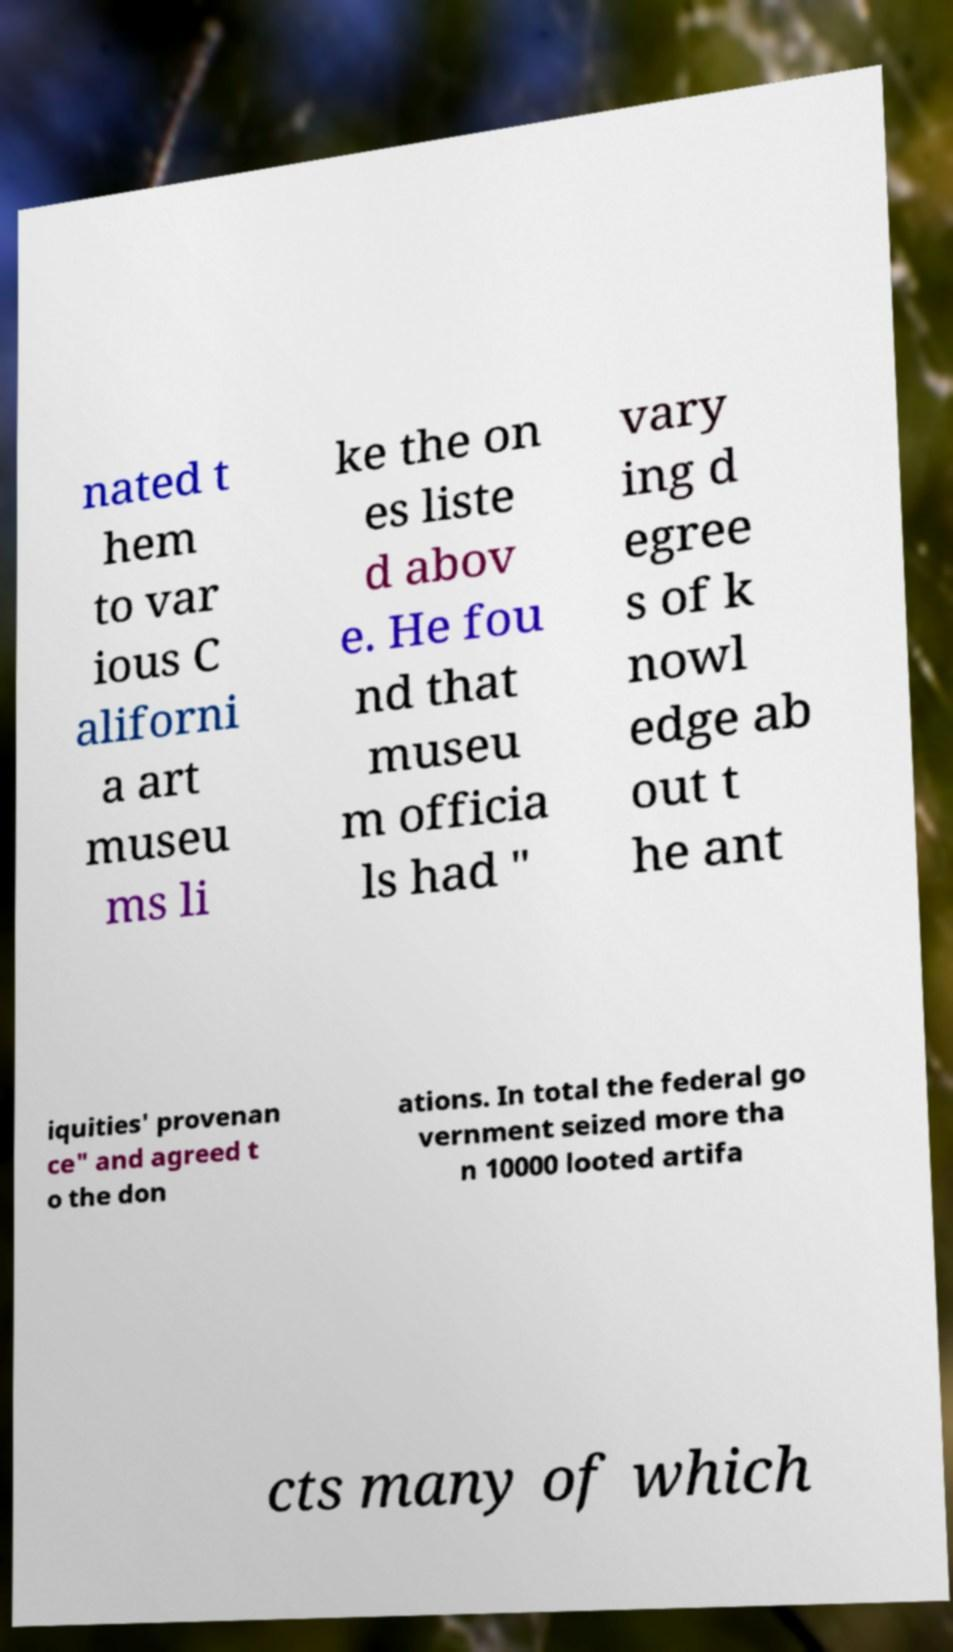There's text embedded in this image that I need extracted. Can you transcribe it verbatim? nated t hem to var ious C aliforni a art museu ms li ke the on es liste d abov e. He fou nd that museu m officia ls had " vary ing d egree s of k nowl edge ab out t he ant iquities' provenan ce" and agreed t o the don ations. In total the federal go vernment seized more tha n 10000 looted artifa cts many of which 